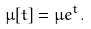<formula> <loc_0><loc_0><loc_500><loc_500>\mu [ t ] = \mu e ^ { t } .</formula> 